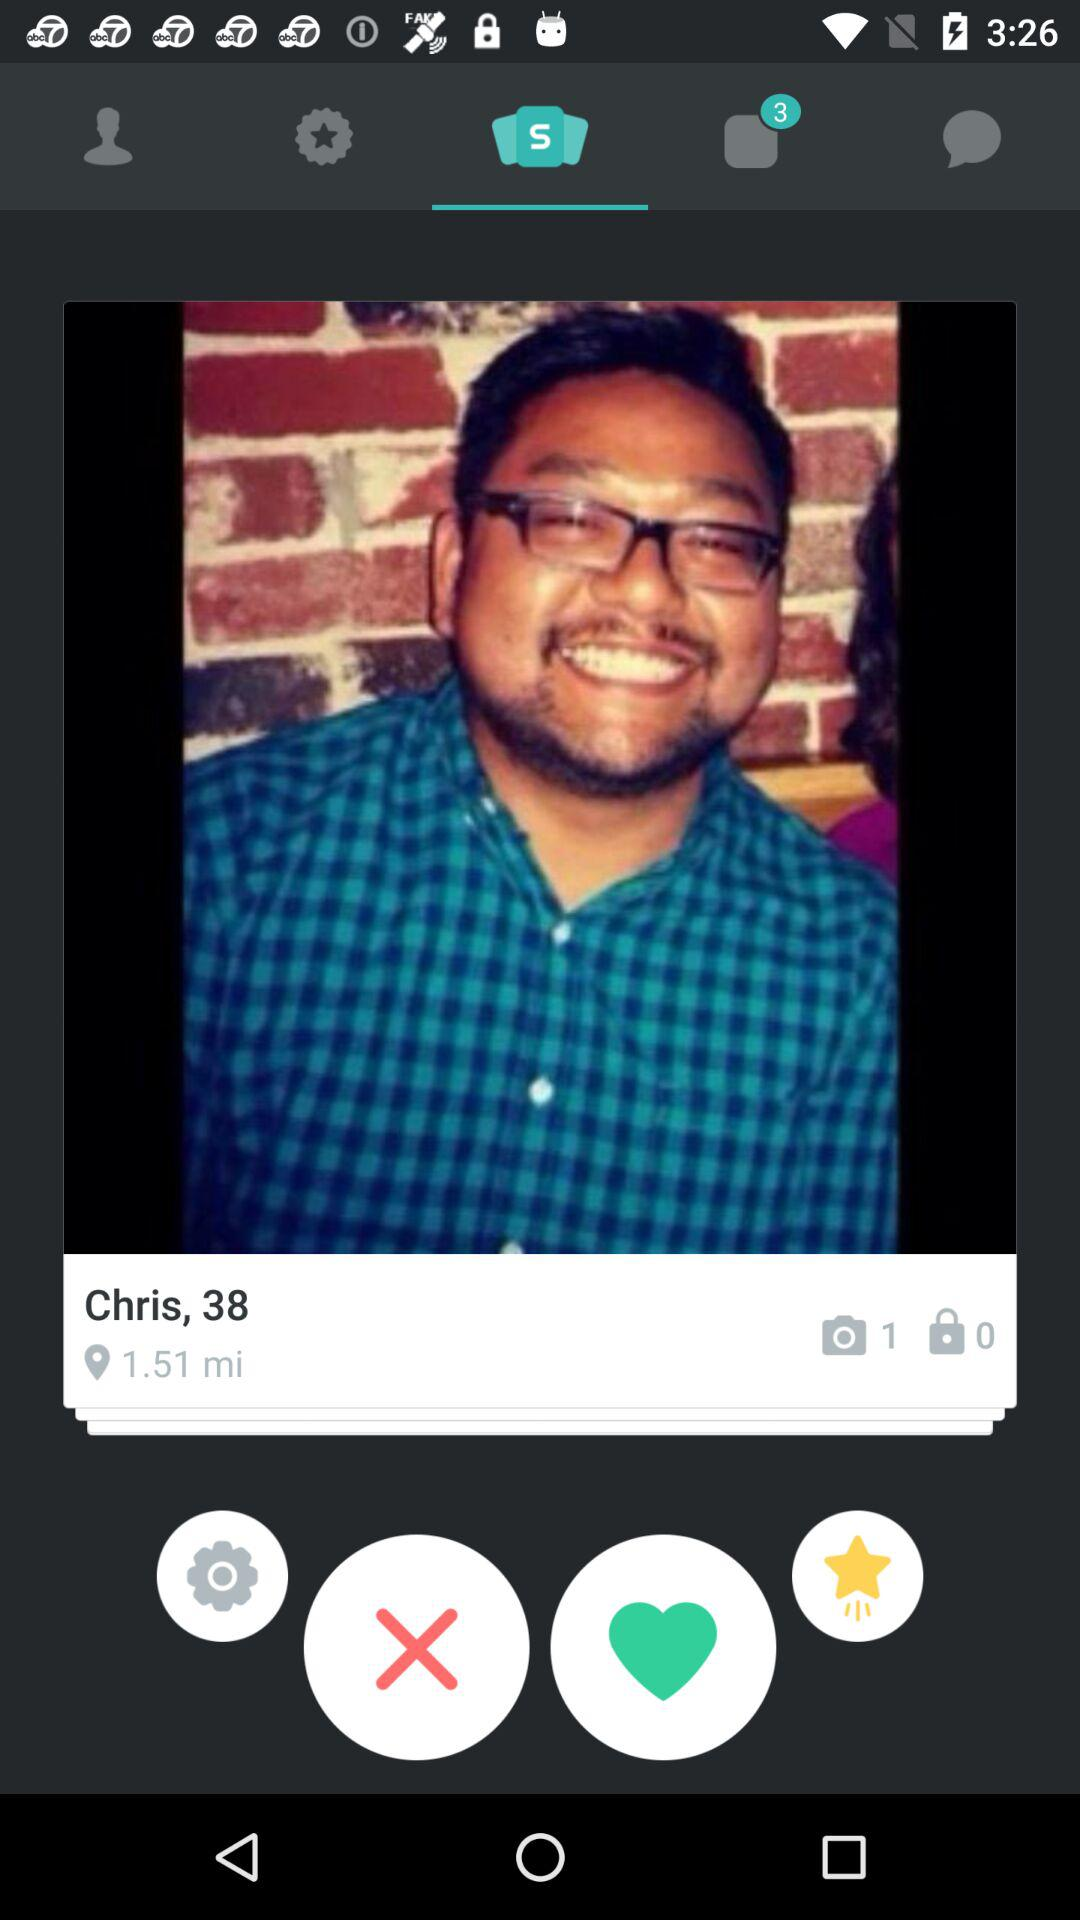What is the distance? The distance is 1.51 miles. 